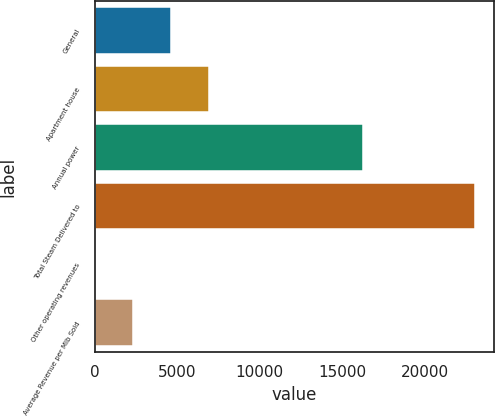<chart> <loc_0><loc_0><loc_500><loc_500><bar_chart><fcel>General<fcel>Apartment house<fcel>Annual power<fcel>Total Steam Delivered to<fcel>Other operating revenues<fcel>Average Revenue per Mlb Sold<nl><fcel>4621<fcel>6920.5<fcel>16269<fcel>23017<fcel>22<fcel>2321.5<nl></chart> 